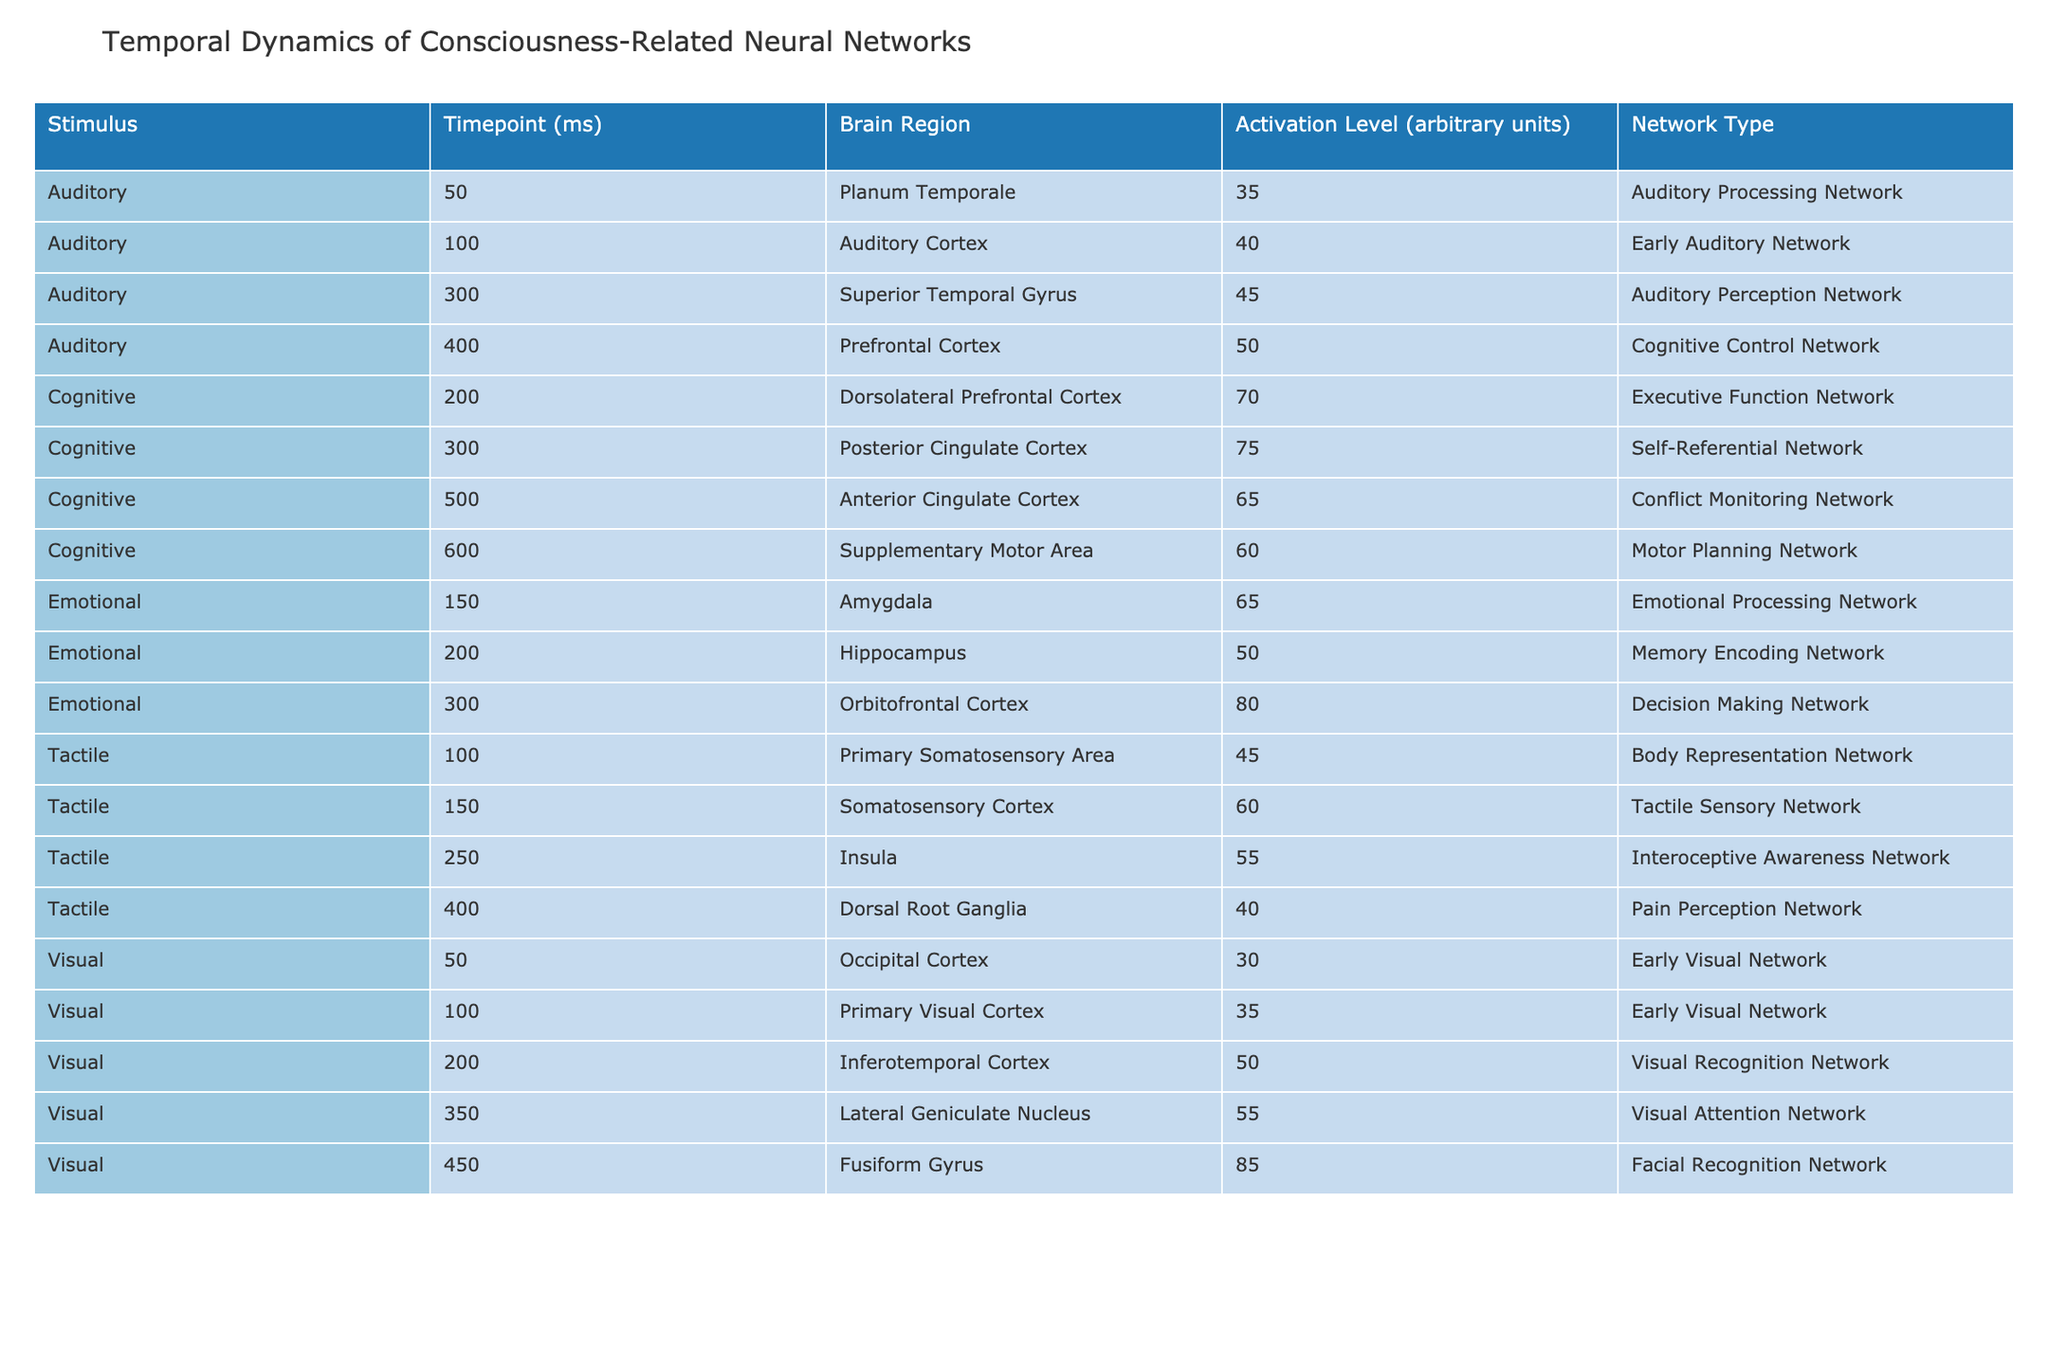What is the activation level of the Amygdala at the 150 ms timepoint? The table shows an entry under the Emotional category for the Amygdala at the 150 ms timepoint, which lists an activation level of 65 arbitrary units.
Answer: 65 Which brain region has the highest activation level among the stimuli listed? Upon reviewing the table, the Fusiform Gyrus under the Visual stimulus at the 450 ms timepoint has the highest activation level of 85 arbitrary units.
Answer: 85 Is the activation level of the Supplementary Motor Area greater than the activation level of the Insula? The activation level of the Supplementary Motor Area is 60 arbitrary units (at 600 ms), while the Insula has an activation level of 55 arbitrary units (at 250 ms). Since 60 is greater than 55, the statement is true.
Answer: Yes What is the average activation level of the networks involved in Cognitive stimuli? The activation levels for Cognitive stimuli are 70 (Dorsolateral Prefrontal Cortex), 75 (Posterior Cingulate Cortex), 65 (Anterior Cingulate Cortex), and 60 (Supplementary Motor Area). To find the average: (70 + 75 + 65 + 60) = 270, and there are 4 entries, so 270/4 = 67.5.
Answer: 67.5 Which stimulus type has the longest delay before the first recorded activation in the table? The first recorded activation for the Visual stimulus occurs at 50 ms, Auditory at 50 ms, Tactile at 100 ms, and Emotional at 150 ms. Thus, Emotional has the longest delay before the first activation timepoint at 150 ms.
Answer: Emotional 